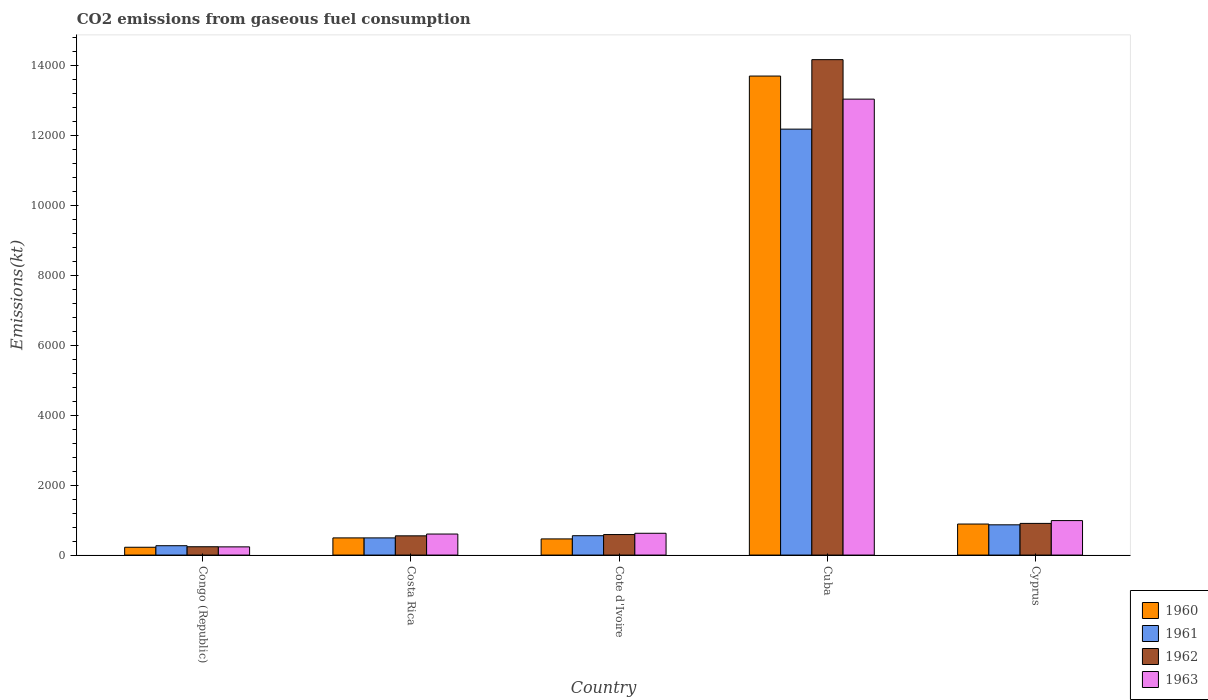How many groups of bars are there?
Your answer should be compact. 5. Are the number of bars per tick equal to the number of legend labels?
Offer a terse response. Yes. How many bars are there on the 2nd tick from the right?
Provide a succinct answer. 4. What is the amount of CO2 emitted in 1960 in Costa Rica?
Keep it short and to the point. 491.38. Across all countries, what is the maximum amount of CO2 emitted in 1962?
Your response must be concise. 1.42e+04. Across all countries, what is the minimum amount of CO2 emitted in 1963?
Your response must be concise. 234.69. In which country was the amount of CO2 emitted in 1962 maximum?
Make the answer very short. Cuba. In which country was the amount of CO2 emitted in 1960 minimum?
Your answer should be compact. Congo (Republic). What is the total amount of CO2 emitted in 1963 in the graph?
Give a very brief answer. 1.55e+04. What is the difference between the amount of CO2 emitted in 1962 in Congo (Republic) and that in Costa Rica?
Offer a very short reply. -311.69. What is the difference between the amount of CO2 emitted in 1961 in Cuba and the amount of CO2 emitted in 1960 in Congo (Republic)?
Your answer should be very brief. 1.20e+04. What is the average amount of CO2 emitted in 1962 per country?
Make the answer very short. 3290.03. What is the difference between the amount of CO2 emitted of/in 1962 and amount of CO2 emitted of/in 1961 in Congo (Republic)?
Keep it short and to the point. -29.34. In how many countries, is the amount of CO2 emitted in 1960 greater than 5600 kt?
Your answer should be very brief. 1. What is the ratio of the amount of CO2 emitted in 1961 in Cote d'Ivoire to that in Cyprus?
Your answer should be compact. 0.64. Is the amount of CO2 emitted in 1962 in Cote d'Ivoire less than that in Cyprus?
Give a very brief answer. Yes. What is the difference between the highest and the second highest amount of CO2 emitted in 1963?
Provide a succinct answer. 363.03. What is the difference between the highest and the lowest amount of CO2 emitted in 1960?
Provide a succinct answer. 1.35e+04. Is it the case that in every country, the sum of the amount of CO2 emitted in 1963 and amount of CO2 emitted in 1962 is greater than the sum of amount of CO2 emitted in 1960 and amount of CO2 emitted in 1961?
Ensure brevity in your answer.  No. How many bars are there?
Your answer should be very brief. 20. Are all the bars in the graph horizontal?
Offer a very short reply. No. How many countries are there in the graph?
Provide a succinct answer. 5. Does the graph contain any zero values?
Ensure brevity in your answer.  No. How are the legend labels stacked?
Your answer should be very brief. Vertical. What is the title of the graph?
Ensure brevity in your answer.  CO2 emissions from gaseous fuel consumption. What is the label or title of the X-axis?
Offer a terse response. Country. What is the label or title of the Y-axis?
Make the answer very short. Emissions(kt). What is the Emissions(kt) of 1960 in Congo (Republic)?
Provide a succinct answer. 223.69. What is the Emissions(kt) of 1961 in Congo (Republic)?
Give a very brief answer. 267.69. What is the Emissions(kt) in 1962 in Congo (Republic)?
Your answer should be compact. 238.35. What is the Emissions(kt) of 1963 in Congo (Republic)?
Your answer should be compact. 234.69. What is the Emissions(kt) in 1960 in Costa Rica?
Your answer should be very brief. 491.38. What is the Emissions(kt) of 1961 in Costa Rica?
Keep it short and to the point. 491.38. What is the Emissions(kt) of 1962 in Costa Rica?
Offer a very short reply. 550.05. What is the Emissions(kt) of 1963 in Costa Rica?
Ensure brevity in your answer.  601.39. What is the Emissions(kt) of 1960 in Cote d'Ivoire?
Your response must be concise. 462.04. What is the Emissions(kt) in 1961 in Cote d'Ivoire?
Your answer should be compact. 553.72. What is the Emissions(kt) of 1962 in Cote d'Ivoire?
Make the answer very short. 586.72. What is the Emissions(kt) in 1963 in Cote d'Ivoire?
Offer a terse response. 623.39. What is the Emissions(kt) of 1960 in Cuba?
Offer a terse response. 1.37e+04. What is the Emissions(kt) in 1961 in Cuba?
Offer a very short reply. 1.22e+04. What is the Emissions(kt) of 1962 in Cuba?
Give a very brief answer. 1.42e+04. What is the Emissions(kt) of 1963 in Cuba?
Keep it short and to the point. 1.30e+04. What is the Emissions(kt) of 1960 in Cyprus?
Offer a terse response. 887.41. What is the Emissions(kt) of 1961 in Cyprus?
Ensure brevity in your answer.  865.41. What is the Emissions(kt) of 1962 in Cyprus?
Ensure brevity in your answer.  905.75. What is the Emissions(kt) in 1963 in Cyprus?
Your response must be concise. 986.42. Across all countries, what is the maximum Emissions(kt) in 1960?
Your answer should be compact. 1.37e+04. Across all countries, what is the maximum Emissions(kt) in 1961?
Your answer should be very brief. 1.22e+04. Across all countries, what is the maximum Emissions(kt) of 1962?
Offer a very short reply. 1.42e+04. Across all countries, what is the maximum Emissions(kt) in 1963?
Provide a succinct answer. 1.30e+04. Across all countries, what is the minimum Emissions(kt) in 1960?
Provide a succinct answer. 223.69. Across all countries, what is the minimum Emissions(kt) of 1961?
Offer a terse response. 267.69. Across all countries, what is the minimum Emissions(kt) of 1962?
Keep it short and to the point. 238.35. Across all countries, what is the minimum Emissions(kt) in 1963?
Your answer should be very brief. 234.69. What is the total Emissions(kt) of 1960 in the graph?
Your response must be concise. 1.58e+04. What is the total Emissions(kt) in 1961 in the graph?
Your answer should be very brief. 1.44e+04. What is the total Emissions(kt) of 1962 in the graph?
Ensure brevity in your answer.  1.65e+04. What is the total Emissions(kt) in 1963 in the graph?
Offer a terse response. 1.55e+04. What is the difference between the Emissions(kt) of 1960 in Congo (Republic) and that in Costa Rica?
Provide a short and direct response. -267.69. What is the difference between the Emissions(kt) of 1961 in Congo (Republic) and that in Costa Rica?
Your answer should be compact. -223.69. What is the difference between the Emissions(kt) of 1962 in Congo (Republic) and that in Costa Rica?
Provide a short and direct response. -311.69. What is the difference between the Emissions(kt) of 1963 in Congo (Republic) and that in Costa Rica?
Your answer should be very brief. -366.7. What is the difference between the Emissions(kt) of 1960 in Congo (Republic) and that in Cote d'Ivoire?
Provide a short and direct response. -238.35. What is the difference between the Emissions(kt) in 1961 in Congo (Republic) and that in Cote d'Ivoire?
Offer a terse response. -286.03. What is the difference between the Emissions(kt) in 1962 in Congo (Republic) and that in Cote d'Ivoire?
Make the answer very short. -348.37. What is the difference between the Emissions(kt) in 1963 in Congo (Republic) and that in Cote d'Ivoire?
Your answer should be compact. -388.7. What is the difference between the Emissions(kt) in 1960 in Congo (Republic) and that in Cuba?
Offer a terse response. -1.35e+04. What is the difference between the Emissions(kt) in 1961 in Congo (Republic) and that in Cuba?
Offer a terse response. -1.19e+04. What is the difference between the Emissions(kt) in 1962 in Congo (Republic) and that in Cuba?
Provide a succinct answer. -1.39e+04. What is the difference between the Emissions(kt) in 1963 in Congo (Republic) and that in Cuba?
Your answer should be very brief. -1.28e+04. What is the difference between the Emissions(kt) of 1960 in Congo (Republic) and that in Cyprus?
Provide a short and direct response. -663.73. What is the difference between the Emissions(kt) of 1961 in Congo (Republic) and that in Cyprus?
Provide a short and direct response. -597.72. What is the difference between the Emissions(kt) of 1962 in Congo (Republic) and that in Cyprus?
Your answer should be very brief. -667.39. What is the difference between the Emissions(kt) of 1963 in Congo (Republic) and that in Cyprus?
Your answer should be compact. -751.74. What is the difference between the Emissions(kt) of 1960 in Costa Rica and that in Cote d'Ivoire?
Make the answer very short. 29.34. What is the difference between the Emissions(kt) in 1961 in Costa Rica and that in Cote d'Ivoire?
Make the answer very short. -62.34. What is the difference between the Emissions(kt) of 1962 in Costa Rica and that in Cote d'Ivoire?
Provide a succinct answer. -36.67. What is the difference between the Emissions(kt) of 1963 in Costa Rica and that in Cote d'Ivoire?
Make the answer very short. -22. What is the difference between the Emissions(kt) of 1960 in Costa Rica and that in Cuba?
Offer a terse response. -1.32e+04. What is the difference between the Emissions(kt) of 1961 in Costa Rica and that in Cuba?
Offer a very short reply. -1.17e+04. What is the difference between the Emissions(kt) in 1962 in Costa Rica and that in Cuba?
Offer a very short reply. -1.36e+04. What is the difference between the Emissions(kt) of 1963 in Costa Rica and that in Cuba?
Give a very brief answer. -1.24e+04. What is the difference between the Emissions(kt) of 1960 in Costa Rica and that in Cyprus?
Provide a succinct answer. -396.04. What is the difference between the Emissions(kt) of 1961 in Costa Rica and that in Cyprus?
Keep it short and to the point. -374.03. What is the difference between the Emissions(kt) in 1962 in Costa Rica and that in Cyprus?
Provide a succinct answer. -355.7. What is the difference between the Emissions(kt) in 1963 in Costa Rica and that in Cyprus?
Provide a succinct answer. -385.04. What is the difference between the Emissions(kt) in 1960 in Cote d'Ivoire and that in Cuba?
Offer a very short reply. -1.32e+04. What is the difference between the Emissions(kt) in 1961 in Cote d'Ivoire and that in Cuba?
Give a very brief answer. -1.16e+04. What is the difference between the Emissions(kt) of 1962 in Cote d'Ivoire and that in Cuba?
Your answer should be very brief. -1.36e+04. What is the difference between the Emissions(kt) of 1963 in Cote d'Ivoire and that in Cuba?
Keep it short and to the point. -1.24e+04. What is the difference between the Emissions(kt) in 1960 in Cote d'Ivoire and that in Cyprus?
Your answer should be compact. -425.37. What is the difference between the Emissions(kt) in 1961 in Cote d'Ivoire and that in Cyprus?
Ensure brevity in your answer.  -311.69. What is the difference between the Emissions(kt) of 1962 in Cote d'Ivoire and that in Cyprus?
Your response must be concise. -319.03. What is the difference between the Emissions(kt) of 1963 in Cote d'Ivoire and that in Cyprus?
Offer a very short reply. -363.03. What is the difference between the Emissions(kt) of 1960 in Cuba and that in Cyprus?
Keep it short and to the point. 1.28e+04. What is the difference between the Emissions(kt) of 1961 in Cuba and that in Cyprus?
Keep it short and to the point. 1.13e+04. What is the difference between the Emissions(kt) of 1962 in Cuba and that in Cyprus?
Offer a terse response. 1.33e+04. What is the difference between the Emissions(kt) of 1963 in Cuba and that in Cyprus?
Your answer should be very brief. 1.21e+04. What is the difference between the Emissions(kt) in 1960 in Congo (Republic) and the Emissions(kt) in 1961 in Costa Rica?
Make the answer very short. -267.69. What is the difference between the Emissions(kt) of 1960 in Congo (Republic) and the Emissions(kt) of 1962 in Costa Rica?
Your response must be concise. -326.36. What is the difference between the Emissions(kt) in 1960 in Congo (Republic) and the Emissions(kt) in 1963 in Costa Rica?
Keep it short and to the point. -377.7. What is the difference between the Emissions(kt) in 1961 in Congo (Republic) and the Emissions(kt) in 1962 in Costa Rica?
Offer a very short reply. -282.36. What is the difference between the Emissions(kt) in 1961 in Congo (Republic) and the Emissions(kt) in 1963 in Costa Rica?
Offer a terse response. -333.7. What is the difference between the Emissions(kt) in 1962 in Congo (Republic) and the Emissions(kt) in 1963 in Costa Rica?
Provide a short and direct response. -363.03. What is the difference between the Emissions(kt) in 1960 in Congo (Republic) and the Emissions(kt) in 1961 in Cote d'Ivoire?
Ensure brevity in your answer.  -330.03. What is the difference between the Emissions(kt) in 1960 in Congo (Republic) and the Emissions(kt) in 1962 in Cote d'Ivoire?
Your answer should be very brief. -363.03. What is the difference between the Emissions(kt) in 1960 in Congo (Republic) and the Emissions(kt) in 1963 in Cote d'Ivoire?
Provide a short and direct response. -399.7. What is the difference between the Emissions(kt) in 1961 in Congo (Republic) and the Emissions(kt) in 1962 in Cote d'Ivoire?
Ensure brevity in your answer.  -319.03. What is the difference between the Emissions(kt) in 1961 in Congo (Republic) and the Emissions(kt) in 1963 in Cote d'Ivoire?
Keep it short and to the point. -355.7. What is the difference between the Emissions(kt) in 1962 in Congo (Republic) and the Emissions(kt) in 1963 in Cote d'Ivoire?
Provide a succinct answer. -385.04. What is the difference between the Emissions(kt) of 1960 in Congo (Republic) and the Emissions(kt) of 1961 in Cuba?
Offer a very short reply. -1.20e+04. What is the difference between the Emissions(kt) in 1960 in Congo (Republic) and the Emissions(kt) in 1962 in Cuba?
Keep it short and to the point. -1.39e+04. What is the difference between the Emissions(kt) of 1960 in Congo (Republic) and the Emissions(kt) of 1963 in Cuba?
Offer a very short reply. -1.28e+04. What is the difference between the Emissions(kt) in 1961 in Congo (Republic) and the Emissions(kt) in 1962 in Cuba?
Offer a terse response. -1.39e+04. What is the difference between the Emissions(kt) in 1961 in Congo (Republic) and the Emissions(kt) in 1963 in Cuba?
Your response must be concise. -1.28e+04. What is the difference between the Emissions(kt) in 1962 in Congo (Republic) and the Emissions(kt) in 1963 in Cuba?
Your response must be concise. -1.28e+04. What is the difference between the Emissions(kt) in 1960 in Congo (Republic) and the Emissions(kt) in 1961 in Cyprus?
Offer a very short reply. -641.73. What is the difference between the Emissions(kt) in 1960 in Congo (Republic) and the Emissions(kt) in 1962 in Cyprus?
Your answer should be very brief. -682.06. What is the difference between the Emissions(kt) in 1960 in Congo (Republic) and the Emissions(kt) in 1963 in Cyprus?
Provide a succinct answer. -762.74. What is the difference between the Emissions(kt) in 1961 in Congo (Republic) and the Emissions(kt) in 1962 in Cyprus?
Make the answer very short. -638.06. What is the difference between the Emissions(kt) of 1961 in Congo (Republic) and the Emissions(kt) of 1963 in Cyprus?
Your answer should be very brief. -718.73. What is the difference between the Emissions(kt) of 1962 in Congo (Republic) and the Emissions(kt) of 1963 in Cyprus?
Your answer should be very brief. -748.07. What is the difference between the Emissions(kt) in 1960 in Costa Rica and the Emissions(kt) in 1961 in Cote d'Ivoire?
Your answer should be very brief. -62.34. What is the difference between the Emissions(kt) in 1960 in Costa Rica and the Emissions(kt) in 1962 in Cote d'Ivoire?
Provide a short and direct response. -95.34. What is the difference between the Emissions(kt) of 1960 in Costa Rica and the Emissions(kt) of 1963 in Cote d'Ivoire?
Provide a succinct answer. -132.01. What is the difference between the Emissions(kt) in 1961 in Costa Rica and the Emissions(kt) in 1962 in Cote d'Ivoire?
Offer a very short reply. -95.34. What is the difference between the Emissions(kt) of 1961 in Costa Rica and the Emissions(kt) of 1963 in Cote d'Ivoire?
Offer a very short reply. -132.01. What is the difference between the Emissions(kt) in 1962 in Costa Rica and the Emissions(kt) in 1963 in Cote d'Ivoire?
Keep it short and to the point. -73.34. What is the difference between the Emissions(kt) of 1960 in Costa Rica and the Emissions(kt) of 1961 in Cuba?
Your answer should be very brief. -1.17e+04. What is the difference between the Emissions(kt) in 1960 in Costa Rica and the Emissions(kt) in 1962 in Cuba?
Provide a short and direct response. -1.37e+04. What is the difference between the Emissions(kt) in 1960 in Costa Rica and the Emissions(kt) in 1963 in Cuba?
Your answer should be compact. -1.25e+04. What is the difference between the Emissions(kt) in 1961 in Costa Rica and the Emissions(kt) in 1962 in Cuba?
Offer a very short reply. -1.37e+04. What is the difference between the Emissions(kt) in 1961 in Costa Rica and the Emissions(kt) in 1963 in Cuba?
Ensure brevity in your answer.  -1.25e+04. What is the difference between the Emissions(kt) in 1962 in Costa Rica and the Emissions(kt) in 1963 in Cuba?
Keep it short and to the point. -1.25e+04. What is the difference between the Emissions(kt) in 1960 in Costa Rica and the Emissions(kt) in 1961 in Cyprus?
Offer a terse response. -374.03. What is the difference between the Emissions(kt) in 1960 in Costa Rica and the Emissions(kt) in 1962 in Cyprus?
Ensure brevity in your answer.  -414.37. What is the difference between the Emissions(kt) in 1960 in Costa Rica and the Emissions(kt) in 1963 in Cyprus?
Make the answer very short. -495.05. What is the difference between the Emissions(kt) in 1961 in Costa Rica and the Emissions(kt) in 1962 in Cyprus?
Make the answer very short. -414.37. What is the difference between the Emissions(kt) in 1961 in Costa Rica and the Emissions(kt) in 1963 in Cyprus?
Ensure brevity in your answer.  -495.05. What is the difference between the Emissions(kt) of 1962 in Costa Rica and the Emissions(kt) of 1963 in Cyprus?
Give a very brief answer. -436.37. What is the difference between the Emissions(kt) of 1960 in Cote d'Ivoire and the Emissions(kt) of 1961 in Cuba?
Ensure brevity in your answer.  -1.17e+04. What is the difference between the Emissions(kt) in 1960 in Cote d'Ivoire and the Emissions(kt) in 1962 in Cuba?
Your answer should be very brief. -1.37e+04. What is the difference between the Emissions(kt) in 1960 in Cote d'Ivoire and the Emissions(kt) in 1963 in Cuba?
Your response must be concise. -1.26e+04. What is the difference between the Emissions(kt) of 1961 in Cote d'Ivoire and the Emissions(kt) of 1962 in Cuba?
Offer a very short reply. -1.36e+04. What is the difference between the Emissions(kt) of 1961 in Cote d'Ivoire and the Emissions(kt) of 1963 in Cuba?
Offer a terse response. -1.25e+04. What is the difference between the Emissions(kt) of 1962 in Cote d'Ivoire and the Emissions(kt) of 1963 in Cuba?
Your response must be concise. -1.25e+04. What is the difference between the Emissions(kt) of 1960 in Cote d'Ivoire and the Emissions(kt) of 1961 in Cyprus?
Offer a very short reply. -403.37. What is the difference between the Emissions(kt) in 1960 in Cote d'Ivoire and the Emissions(kt) in 1962 in Cyprus?
Your answer should be very brief. -443.71. What is the difference between the Emissions(kt) of 1960 in Cote d'Ivoire and the Emissions(kt) of 1963 in Cyprus?
Your response must be concise. -524.38. What is the difference between the Emissions(kt) of 1961 in Cote d'Ivoire and the Emissions(kt) of 1962 in Cyprus?
Give a very brief answer. -352.03. What is the difference between the Emissions(kt) of 1961 in Cote d'Ivoire and the Emissions(kt) of 1963 in Cyprus?
Keep it short and to the point. -432.71. What is the difference between the Emissions(kt) of 1962 in Cote d'Ivoire and the Emissions(kt) of 1963 in Cyprus?
Ensure brevity in your answer.  -399.7. What is the difference between the Emissions(kt) of 1960 in Cuba and the Emissions(kt) of 1961 in Cyprus?
Provide a short and direct response. 1.28e+04. What is the difference between the Emissions(kt) in 1960 in Cuba and the Emissions(kt) in 1962 in Cyprus?
Your answer should be very brief. 1.28e+04. What is the difference between the Emissions(kt) of 1960 in Cuba and the Emissions(kt) of 1963 in Cyprus?
Your answer should be very brief. 1.27e+04. What is the difference between the Emissions(kt) of 1961 in Cuba and the Emissions(kt) of 1962 in Cyprus?
Keep it short and to the point. 1.13e+04. What is the difference between the Emissions(kt) of 1961 in Cuba and the Emissions(kt) of 1963 in Cyprus?
Your answer should be compact. 1.12e+04. What is the difference between the Emissions(kt) of 1962 in Cuba and the Emissions(kt) of 1963 in Cyprus?
Provide a short and direct response. 1.32e+04. What is the average Emissions(kt) of 1960 per country?
Your answer should be compact. 3152.89. What is the average Emissions(kt) of 1961 per country?
Offer a terse response. 2871.99. What is the average Emissions(kt) in 1962 per country?
Your answer should be very brief. 3290.03. What is the average Emissions(kt) of 1963 per country?
Provide a succinct answer. 3097.15. What is the difference between the Emissions(kt) of 1960 and Emissions(kt) of 1961 in Congo (Republic)?
Your answer should be compact. -44. What is the difference between the Emissions(kt) in 1960 and Emissions(kt) in 1962 in Congo (Republic)?
Make the answer very short. -14.67. What is the difference between the Emissions(kt) of 1960 and Emissions(kt) of 1963 in Congo (Republic)?
Your response must be concise. -11. What is the difference between the Emissions(kt) of 1961 and Emissions(kt) of 1962 in Congo (Republic)?
Your response must be concise. 29.34. What is the difference between the Emissions(kt) in 1961 and Emissions(kt) in 1963 in Congo (Republic)?
Offer a very short reply. 33. What is the difference between the Emissions(kt) in 1962 and Emissions(kt) in 1963 in Congo (Republic)?
Your answer should be compact. 3.67. What is the difference between the Emissions(kt) in 1960 and Emissions(kt) in 1961 in Costa Rica?
Make the answer very short. 0. What is the difference between the Emissions(kt) in 1960 and Emissions(kt) in 1962 in Costa Rica?
Ensure brevity in your answer.  -58.67. What is the difference between the Emissions(kt) of 1960 and Emissions(kt) of 1963 in Costa Rica?
Ensure brevity in your answer.  -110.01. What is the difference between the Emissions(kt) in 1961 and Emissions(kt) in 1962 in Costa Rica?
Provide a succinct answer. -58.67. What is the difference between the Emissions(kt) of 1961 and Emissions(kt) of 1963 in Costa Rica?
Make the answer very short. -110.01. What is the difference between the Emissions(kt) of 1962 and Emissions(kt) of 1963 in Costa Rica?
Make the answer very short. -51.34. What is the difference between the Emissions(kt) of 1960 and Emissions(kt) of 1961 in Cote d'Ivoire?
Offer a very short reply. -91.67. What is the difference between the Emissions(kt) in 1960 and Emissions(kt) in 1962 in Cote d'Ivoire?
Provide a short and direct response. -124.68. What is the difference between the Emissions(kt) in 1960 and Emissions(kt) in 1963 in Cote d'Ivoire?
Your answer should be compact. -161.35. What is the difference between the Emissions(kt) in 1961 and Emissions(kt) in 1962 in Cote d'Ivoire?
Provide a short and direct response. -33. What is the difference between the Emissions(kt) in 1961 and Emissions(kt) in 1963 in Cote d'Ivoire?
Give a very brief answer. -69.67. What is the difference between the Emissions(kt) of 1962 and Emissions(kt) of 1963 in Cote d'Ivoire?
Keep it short and to the point. -36.67. What is the difference between the Emissions(kt) of 1960 and Emissions(kt) of 1961 in Cuba?
Your answer should be very brief. 1518.14. What is the difference between the Emissions(kt) in 1960 and Emissions(kt) in 1962 in Cuba?
Provide a short and direct response. -469.38. What is the difference between the Emissions(kt) of 1960 and Emissions(kt) of 1963 in Cuba?
Your answer should be compact. 660.06. What is the difference between the Emissions(kt) in 1961 and Emissions(kt) in 1962 in Cuba?
Your answer should be compact. -1987.51. What is the difference between the Emissions(kt) in 1961 and Emissions(kt) in 1963 in Cuba?
Provide a succinct answer. -858.08. What is the difference between the Emissions(kt) of 1962 and Emissions(kt) of 1963 in Cuba?
Your response must be concise. 1129.44. What is the difference between the Emissions(kt) in 1960 and Emissions(kt) in 1961 in Cyprus?
Provide a short and direct response. 22. What is the difference between the Emissions(kt) in 1960 and Emissions(kt) in 1962 in Cyprus?
Keep it short and to the point. -18.34. What is the difference between the Emissions(kt) in 1960 and Emissions(kt) in 1963 in Cyprus?
Provide a succinct answer. -99.01. What is the difference between the Emissions(kt) of 1961 and Emissions(kt) of 1962 in Cyprus?
Your response must be concise. -40.34. What is the difference between the Emissions(kt) of 1961 and Emissions(kt) of 1963 in Cyprus?
Offer a very short reply. -121.01. What is the difference between the Emissions(kt) of 1962 and Emissions(kt) of 1963 in Cyprus?
Your response must be concise. -80.67. What is the ratio of the Emissions(kt) in 1960 in Congo (Republic) to that in Costa Rica?
Your answer should be very brief. 0.46. What is the ratio of the Emissions(kt) of 1961 in Congo (Republic) to that in Costa Rica?
Ensure brevity in your answer.  0.54. What is the ratio of the Emissions(kt) of 1962 in Congo (Republic) to that in Costa Rica?
Give a very brief answer. 0.43. What is the ratio of the Emissions(kt) in 1963 in Congo (Republic) to that in Costa Rica?
Keep it short and to the point. 0.39. What is the ratio of the Emissions(kt) in 1960 in Congo (Republic) to that in Cote d'Ivoire?
Provide a short and direct response. 0.48. What is the ratio of the Emissions(kt) of 1961 in Congo (Republic) to that in Cote d'Ivoire?
Make the answer very short. 0.48. What is the ratio of the Emissions(kt) in 1962 in Congo (Republic) to that in Cote d'Ivoire?
Your answer should be compact. 0.41. What is the ratio of the Emissions(kt) of 1963 in Congo (Republic) to that in Cote d'Ivoire?
Offer a terse response. 0.38. What is the ratio of the Emissions(kt) in 1960 in Congo (Republic) to that in Cuba?
Keep it short and to the point. 0.02. What is the ratio of the Emissions(kt) of 1961 in Congo (Republic) to that in Cuba?
Your response must be concise. 0.02. What is the ratio of the Emissions(kt) of 1962 in Congo (Republic) to that in Cuba?
Provide a succinct answer. 0.02. What is the ratio of the Emissions(kt) of 1963 in Congo (Republic) to that in Cuba?
Make the answer very short. 0.02. What is the ratio of the Emissions(kt) of 1960 in Congo (Republic) to that in Cyprus?
Your answer should be very brief. 0.25. What is the ratio of the Emissions(kt) of 1961 in Congo (Republic) to that in Cyprus?
Ensure brevity in your answer.  0.31. What is the ratio of the Emissions(kt) in 1962 in Congo (Republic) to that in Cyprus?
Provide a succinct answer. 0.26. What is the ratio of the Emissions(kt) of 1963 in Congo (Republic) to that in Cyprus?
Provide a succinct answer. 0.24. What is the ratio of the Emissions(kt) of 1960 in Costa Rica to that in Cote d'Ivoire?
Ensure brevity in your answer.  1.06. What is the ratio of the Emissions(kt) of 1961 in Costa Rica to that in Cote d'Ivoire?
Give a very brief answer. 0.89. What is the ratio of the Emissions(kt) in 1962 in Costa Rica to that in Cote d'Ivoire?
Offer a terse response. 0.94. What is the ratio of the Emissions(kt) in 1963 in Costa Rica to that in Cote d'Ivoire?
Your answer should be compact. 0.96. What is the ratio of the Emissions(kt) of 1960 in Costa Rica to that in Cuba?
Provide a short and direct response. 0.04. What is the ratio of the Emissions(kt) in 1961 in Costa Rica to that in Cuba?
Your answer should be compact. 0.04. What is the ratio of the Emissions(kt) of 1962 in Costa Rica to that in Cuba?
Your answer should be compact. 0.04. What is the ratio of the Emissions(kt) in 1963 in Costa Rica to that in Cuba?
Your answer should be very brief. 0.05. What is the ratio of the Emissions(kt) of 1960 in Costa Rica to that in Cyprus?
Keep it short and to the point. 0.55. What is the ratio of the Emissions(kt) in 1961 in Costa Rica to that in Cyprus?
Offer a terse response. 0.57. What is the ratio of the Emissions(kt) of 1962 in Costa Rica to that in Cyprus?
Ensure brevity in your answer.  0.61. What is the ratio of the Emissions(kt) of 1963 in Costa Rica to that in Cyprus?
Your answer should be compact. 0.61. What is the ratio of the Emissions(kt) in 1960 in Cote d'Ivoire to that in Cuba?
Make the answer very short. 0.03. What is the ratio of the Emissions(kt) of 1961 in Cote d'Ivoire to that in Cuba?
Your response must be concise. 0.05. What is the ratio of the Emissions(kt) of 1962 in Cote d'Ivoire to that in Cuba?
Offer a very short reply. 0.04. What is the ratio of the Emissions(kt) in 1963 in Cote d'Ivoire to that in Cuba?
Your response must be concise. 0.05. What is the ratio of the Emissions(kt) of 1960 in Cote d'Ivoire to that in Cyprus?
Provide a short and direct response. 0.52. What is the ratio of the Emissions(kt) of 1961 in Cote d'Ivoire to that in Cyprus?
Give a very brief answer. 0.64. What is the ratio of the Emissions(kt) in 1962 in Cote d'Ivoire to that in Cyprus?
Make the answer very short. 0.65. What is the ratio of the Emissions(kt) in 1963 in Cote d'Ivoire to that in Cyprus?
Ensure brevity in your answer.  0.63. What is the ratio of the Emissions(kt) in 1960 in Cuba to that in Cyprus?
Offer a very short reply. 15.44. What is the ratio of the Emissions(kt) of 1961 in Cuba to that in Cyprus?
Make the answer very short. 14.08. What is the ratio of the Emissions(kt) of 1962 in Cuba to that in Cyprus?
Provide a succinct answer. 15.64. What is the ratio of the Emissions(kt) in 1963 in Cuba to that in Cyprus?
Ensure brevity in your answer.  13.22. What is the difference between the highest and the second highest Emissions(kt) of 1960?
Ensure brevity in your answer.  1.28e+04. What is the difference between the highest and the second highest Emissions(kt) in 1961?
Your answer should be very brief. 1.13e+04. What is the difference between the highest and the second highest Emissions(kt) in 1962?
Offer a very short reply. 1.33e+04. What is the difference between the highest and the second highest Emissions(kt) of 1963?
Provide a short and direct response. 1.21e+04. What is the difference between the highest and the lowest Emissions(kt) of 1960?
Your answer should be very brief. 1.35e+04. What is the difference between the highest and the lowest Emissions(kt) in 1961?
Make the answer very short. 1.19e+04. What is the difference between the highest and the lowest Emissions(kt) in 1962?
Ensure brevity in your answer.  1.39e+04. What is the difference between the highest and the lowest Emissions(kt) in 1963?
Your answer should be compact. 1.28e+04. 